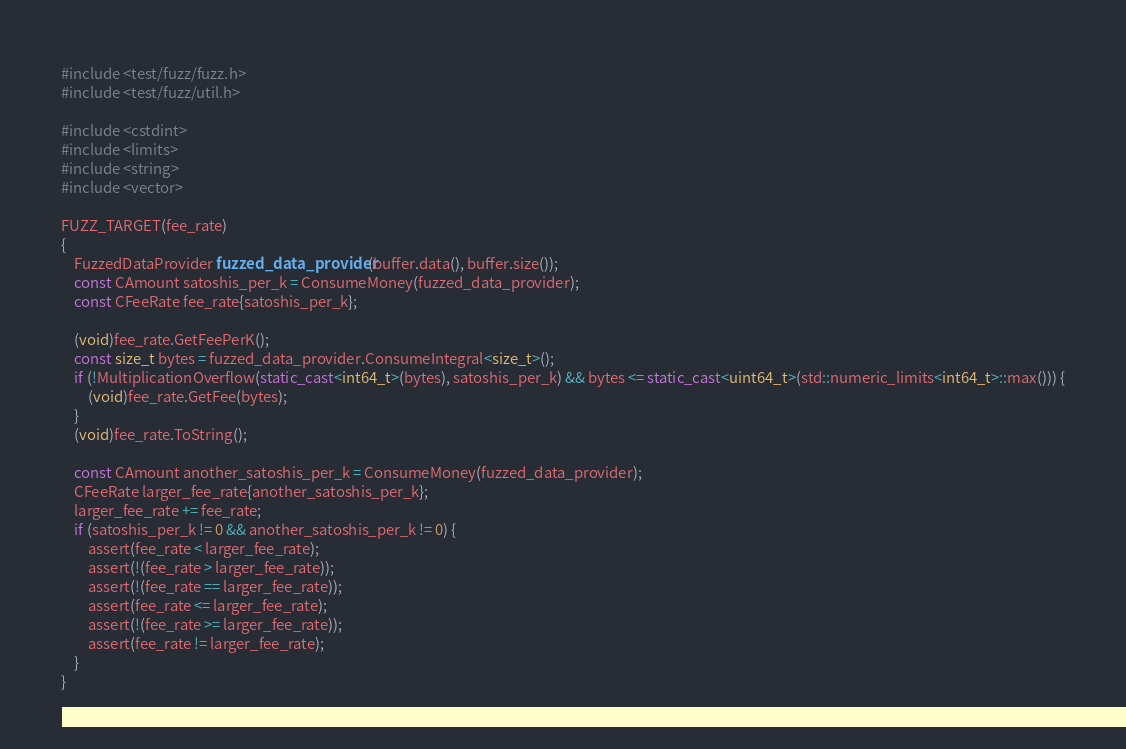<code> <loc_0><loc_0><loc_500><loc_500><_C++_>#include <test/fuzz/fuzz.h>
#include <test/fuzz/util.h>

#include <cstdint>
#include <limits>
#include <string>
#include <vector>

FUZZ_TARGET(fee_rate)
{
    FuzzedDataProvider fuzzed_data_provider(buffer.data(), buffer.size());
    const CAmount satoshis_per_k = ConsumeMoney(fuzzed_data_provider);
    const CFeeRate fee_rate{satoshis_per_k};

    (void)fee_rate.GetFeePerK();
    const size_t bytes = fuzzed_data_provider.ConsumeIntegral<size_t>();
    if (!MultiplicationOverflow(static_cast<int64_t>(bytes), satoshis_per_k) && bytes <= static_cast<uint64_t>(std::numeric_limits<int64_t>::max())) {
        (void)fee_rate.GetFee(bytes);
    }
    (void)fee_rate.ToString();

    const CAmount another_satoshis_per_k = ConsumeMoney(fuzzed_data_provider);
    CFeeRate larger_fee_rate{another_satoshis_per_k};
    larger_fee_rate += fee_rate;
    if (satoshis_per_k != 0 && another_satoshis_per_k != 0) {
        assert(fee_rate < larger_fee_rate);
        assert(!(fee_rate > larger_fee_rate));
        assert(!(fee_rate == larger_fee_rate));
        assert(fee_rate <= larger_fee_rate);
        assert(!(fee_rate >= larger_fee_rate));
        assert(fee_rate != larger_fee_rate);
    }
}
</code> 